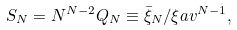Convert formula to latex. <formula><loc_0><loc_0><loc_500><loc_500>S _ { N } = N ^ { N - 2 } Q _ { N } \equiv \bar { \xi } _ { N } / \xi a v ^ { N - 1 } ,</formula> 